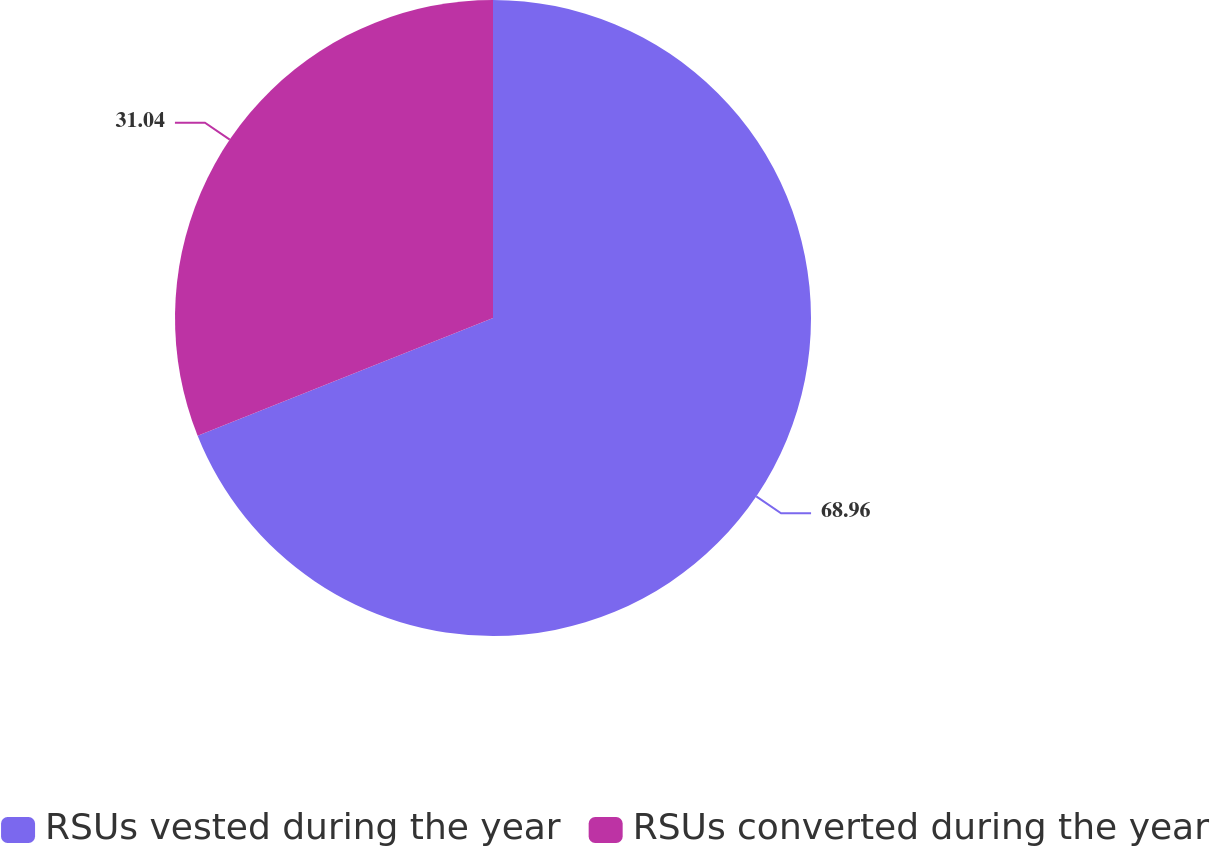Convert chart. <chart><loc_0><loc_0><loc_500><loc_500><pie_chart><fcel>RSUs vested during the year<fcel>RSUs converted during the year<nl><fcel>68.96%<fcel>31.04%<nl></chart> 